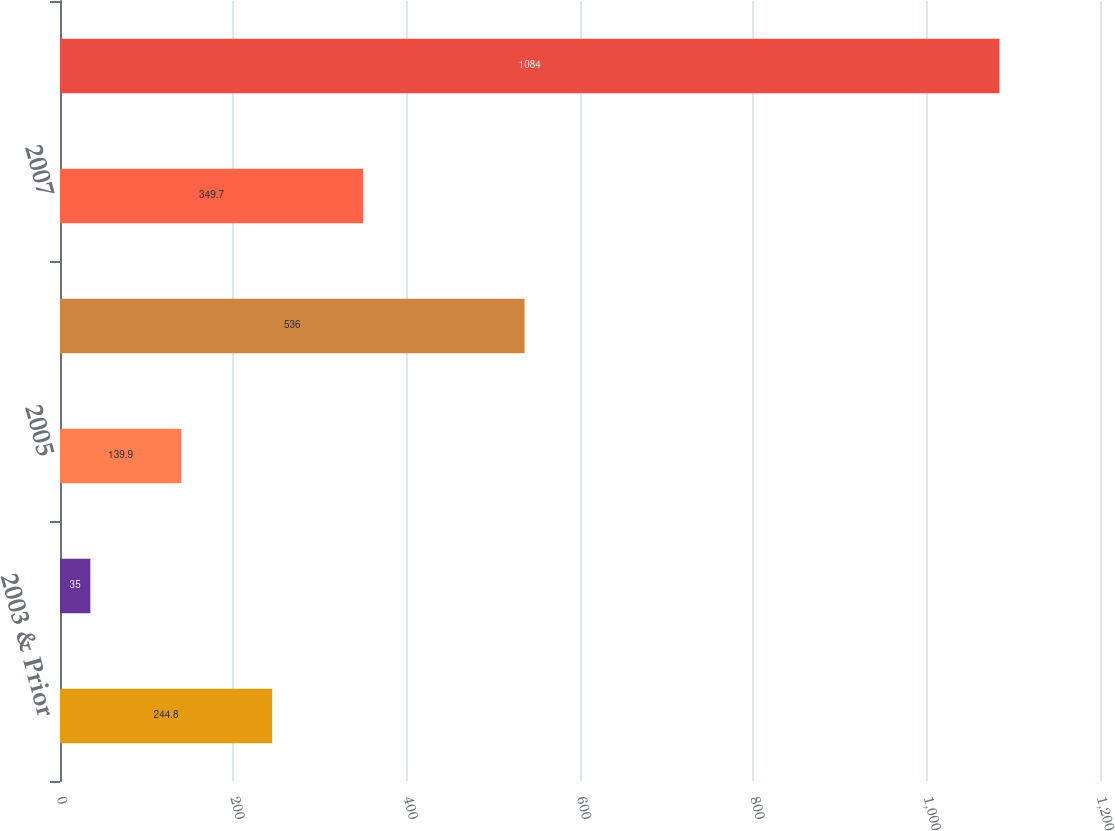Convert chart to OTSL. <chart><loc_0><loc_0><loc_500><loc_500><bar_chart><fcel>2003 & Prior<fcel>2004<fcel>2005<fcel>2006<fcel>2007<fcel>Total<nl><fcel>244.8<fcel>35<fcel>139.9<fcel>536<fcel>349.7<fcel>1084<nl></chart> 